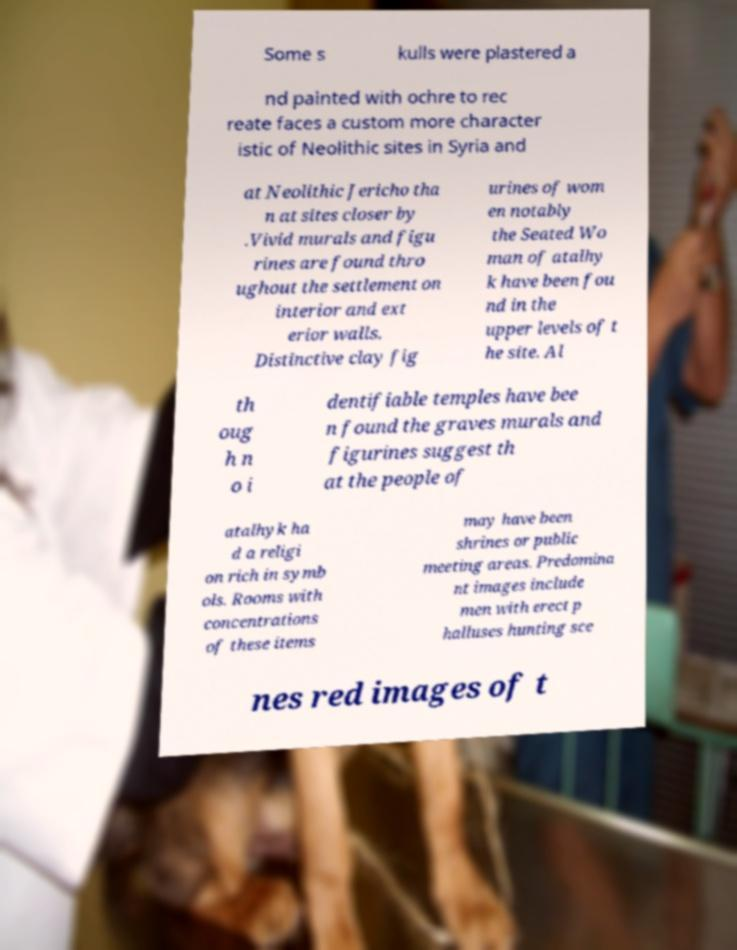Please identify and transcribe the text found in this image. Some s kulls were plastered a nd painted with ochre to rec reate faces a custom more character istic of Neolithic sites in Syria and at Neolithic Jericho tha n at sites closer by .Vivid murals and figu rines are found thro ughout the settlement on interior and ext erior walls. Distinctive clay fig urines of wom en notably the Seated Wo man of atalhy k have been fou nd in the upper levels of t he site. Al th oug h n o i dentifiable temples have bee n found the graves murals and figurines suggest th at the people of atalhyk ha d a religi on rich in symb ols. Rooms with concentrations of these items may have been shrines or public meeting areas. Predomina nt images include men with erect p halluses hunting sce nes red images of t 